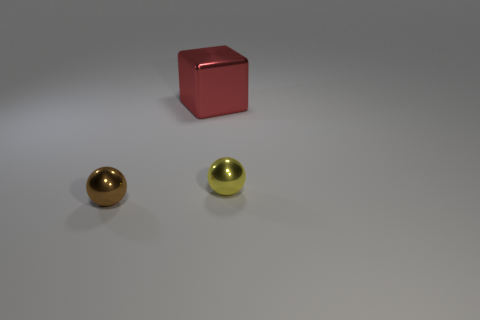Are there any cyan shiny cylinders of the same size as the cube? After inspecting the image, it appears there are no objects that match the description of being cyan-colored cylinders. However, there are two shiny spheres present, one gold-colored and the other silver-colored, alongside a red cube. None of these objects resembles a cylinder in shape. 